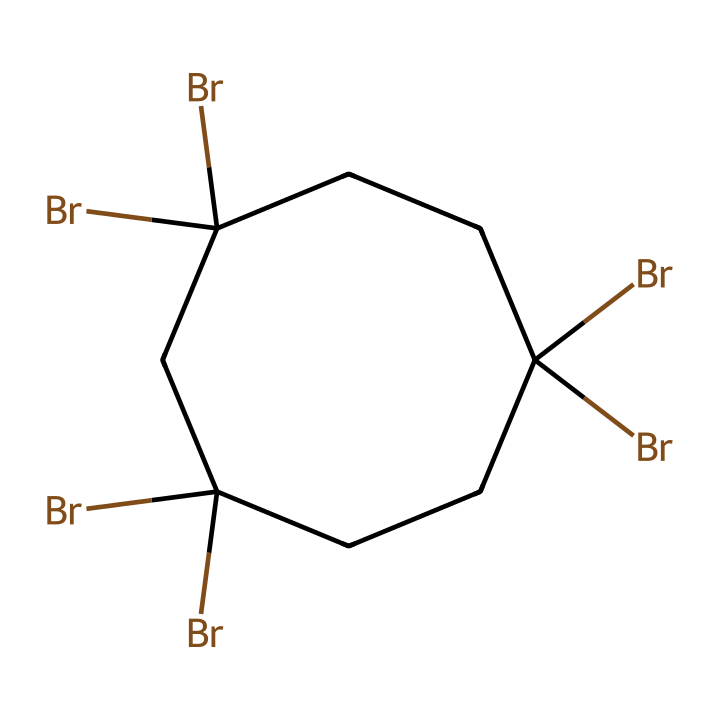What is the total number of carbon atoms in this compound? The SMILES representation indicates the structure of a cycloheptane with multiple bromine substituents. By interpreting the structure, we see there are 7 carbon atoms in the ring.
Answer: 7 How many bromine atoms are present in the compound? The SMILES structure includes "(Br)" at multiple positions, indicating that each occurrence corresponds to a bromine atom attached to a carbon. Counting these occurrences reveals there are 6 bromine atoms present.
Answer: 6 What is the degree of saturation of this compound? The degree of saturation can be determined by examining the number of cycles and double bonds. As a cycloalkane with no double bonds, cycloheptane has a degree of saturation of 1 due to the ring structure. However, for each bromine substitution, a hydrogen is replaced, indicating one less degree of saturation.
Answer: 1 What type of chemical structure is represented? The structure shows a cyclic arrangement of carbon atoms and substituents, indicating it is a cycloalkane. The specific arrangement of carbon atoms forms a seven-membered ring.
Answer: cycloalkane What might be the primary application of this compound in Unix server rack enclosures? Given the presence of bromine, which is known for its flame-retardant properties, this compound could be utilized primarily for flame retardancy in materials used for server rack enclosures.
Answer: flame retardancy How does the presence of bromine influence the flammability of this compound? Bromine is a well-known flame retardant because it interrupts combustion processes. The presence of bromine atoms in the compound decreases the flammability, making it safer for applications involving heat and fire hazards.
Answer: decreases flammability 